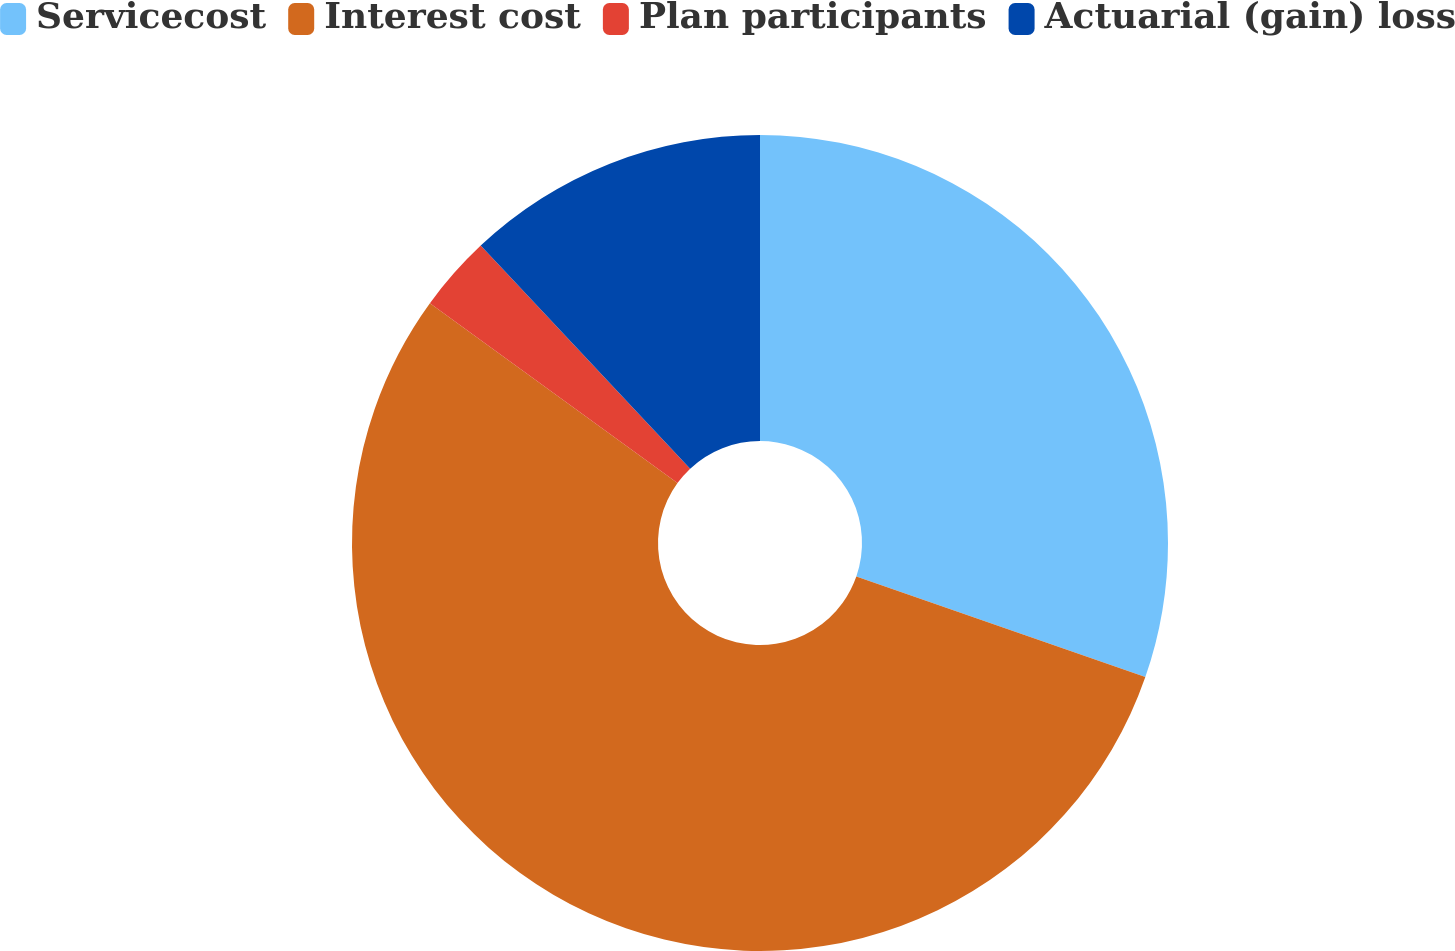Convert chart. <chart><loc_0><loc_0><loc_500><loc_500><pie_chart><fcel>Servicecost<fcel>Interest cost<fcel>Plan participants<fcel>Actuarial (gain) loss<nl><fcel>30.33%<fcel>54.67%<fcel>3.0%<fcel>12.0%<nl></chart> 